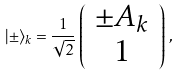<formula> <loc_0><loc_0><loc_500><loc_500>| \pm \rangle _ { k } = \frac { 1 } { \sqrt { 2 } } \, \left ( \begin{array} { c } \pm A _ { k } \\ 1 \end{array} \right ) \, ,</formula> 